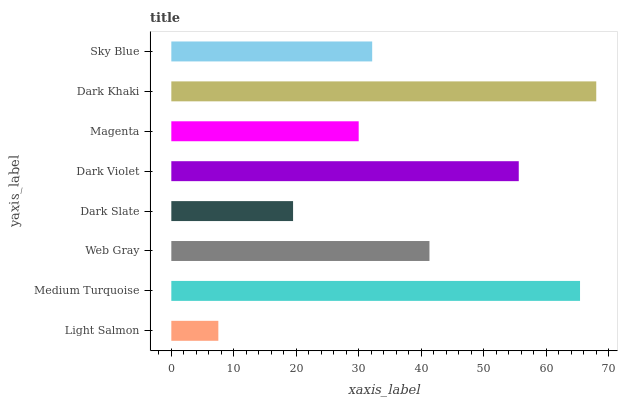Is Light Salmon the minimum?
Answer yes or no. Yes. Is Dark Khaki the maximum?
Answer yes or no. Yes. Is Medium Turquoise the minimum?
Answer yes or no. No. Is Medium Turquoise the maximum?
Answer yes or no. No. Is Medium Turquoise greater than Light Salmon?
Answer yes or no. Yes. Is Light Salmon less than Medium Turquoise?
Answer yes or no. Yes. Is Light Salmon greater than Medium Turquoise?
Answer yes or no. No. Is Medium Turquoise less than Light Salmon?
Answer yes or no. No. Is Web Gray the high median?
Answer yes or no. Yes. Is Sky Blue the low median?
Answer yes or no. Yes. Is Dark Khaki the high median?
Answer yes or no. No. Is Light Salmon the low median?
Answer yes or no. No. 